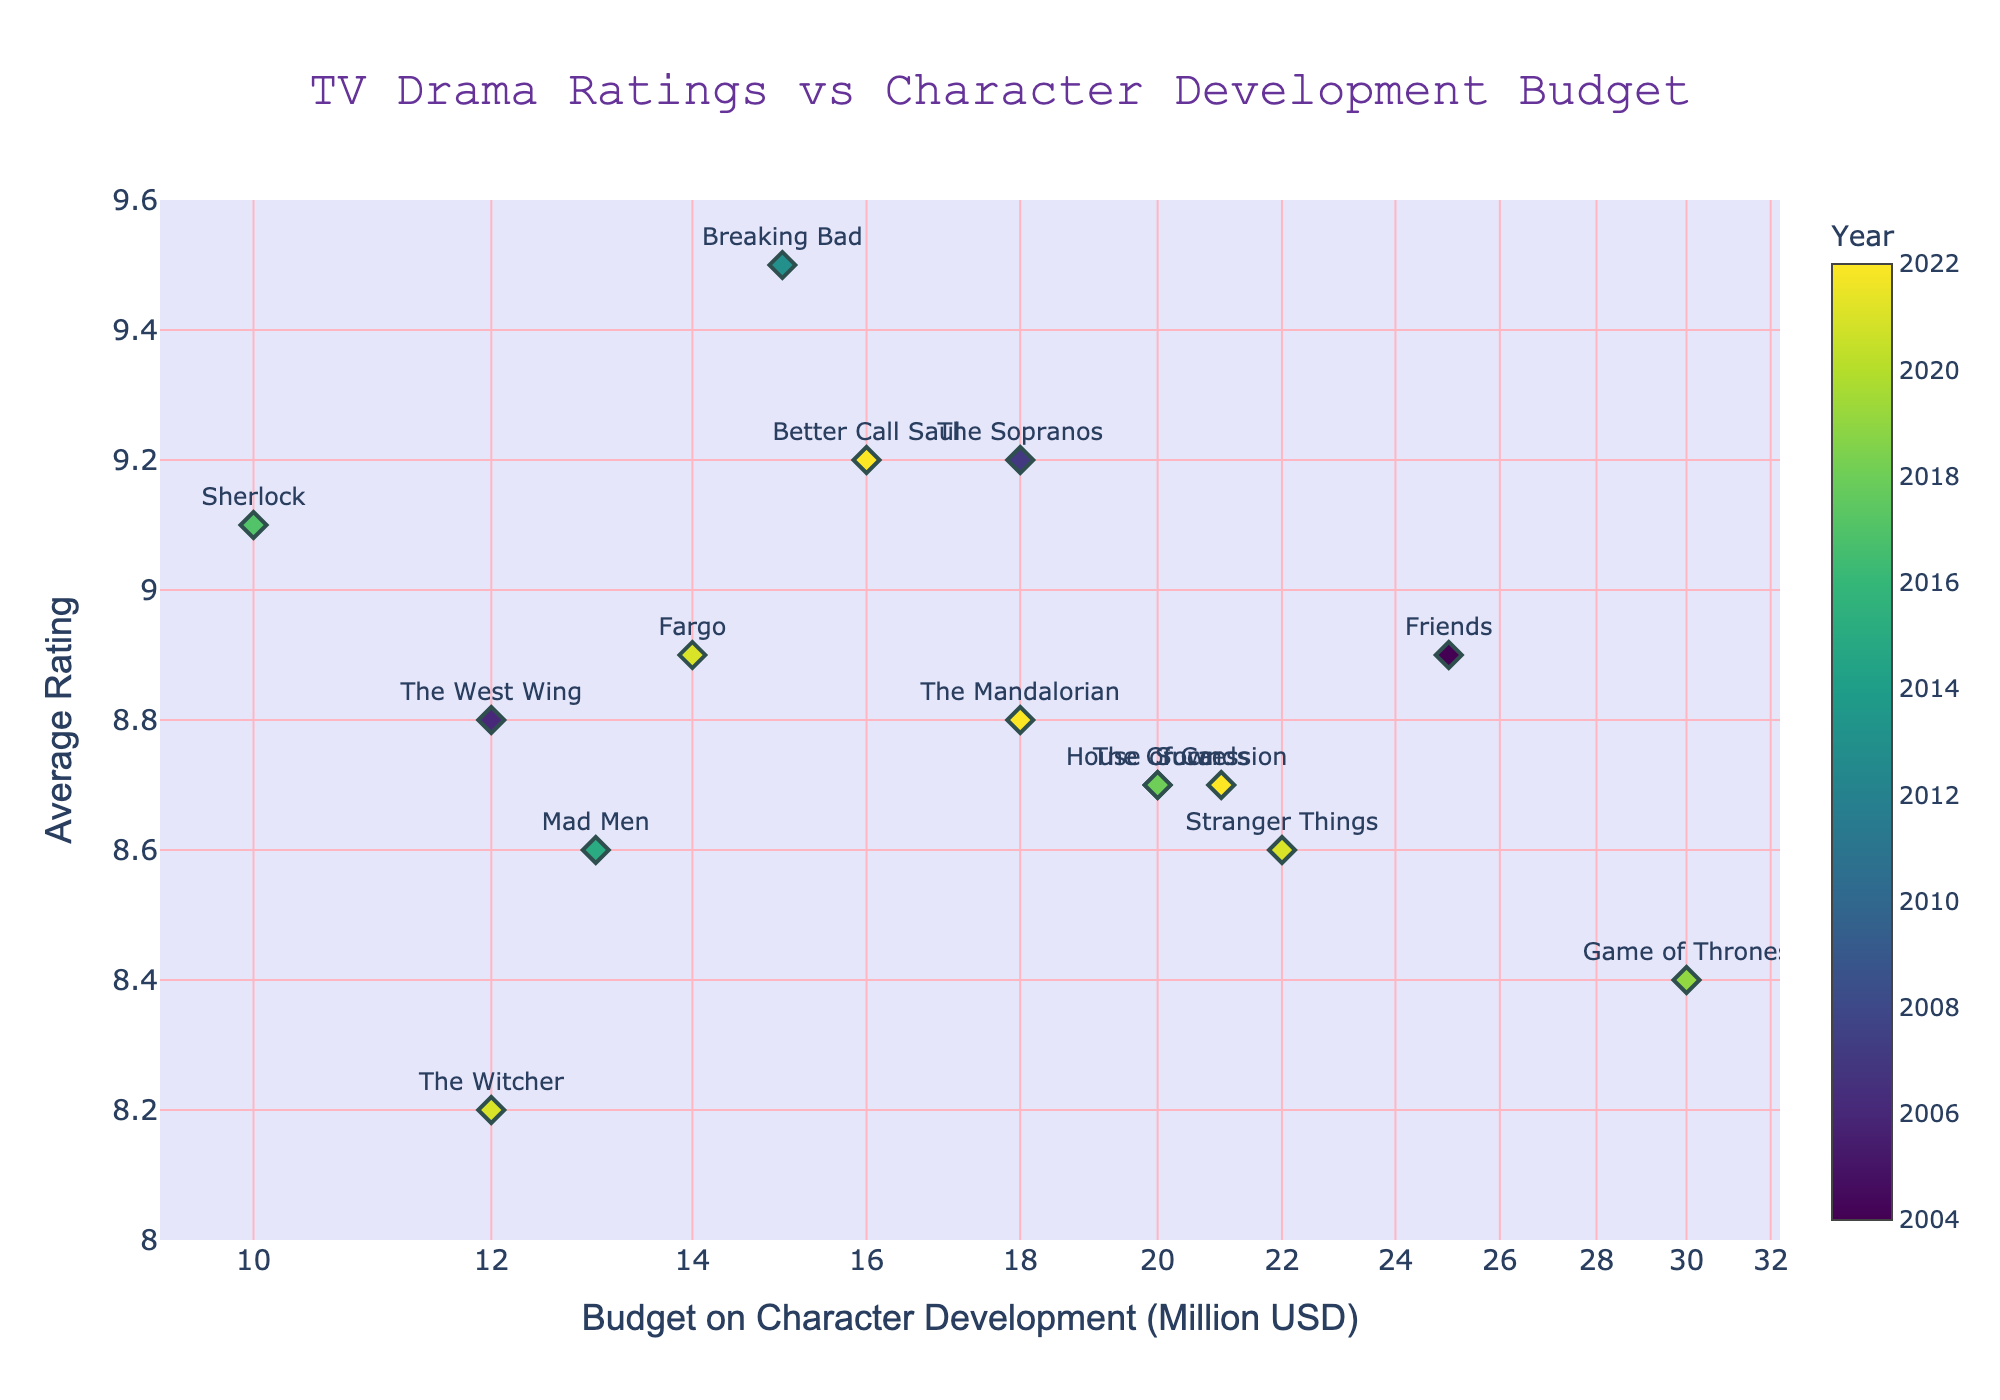What's the title of the plot? Look at the large, centrally aligned text at the top of the plot.
Answer: TV Drama Ratings vs Character Development Budget What is the budget on character development for 'Friends' and its rating? Hover over the data point labeled 'Friends' to see the budget and rating details in the hover template.
Answer: $25M, 8.9 Which TV drama has the highest average rating and what is that rating? Look for the data point at the highest y-axis value and read the label.
Answer: Breaking Bad, 9.5 How does the rating of 'Stranger Things' compare to 'The Witcher'? Locate the data points for 'Stranger Things' and 'The Witcher' and compare their y-axis values (ratings).
Answer: Stranger Things has a higher rating What is the range of budget values shown in the plot? Observe the x-axis, which is on a log scale, to determine the lowest and highest budgets.
Answer: From $10M to $30M How do the budgets of 'Game of Thrones' and 'Succession' compare? Compare the x-axis positions (budget values) of the data points for 'Game of Thrones' and 'Succession'.
Answer: Game of Thrones has a higher budget Which TV drama from 2021 has the highest rating and what is that rating? Identify the data points from the year 2021 and check their y-axis values to find the highest rating.
Answer: Fargo, 8.9 Calculate the average rating of TV dramas with a budget less than $20M. Identify the data points with an x-axis value less than 20 and calculate their average y-axis value. (Breaking Bad: 9.5, The Sopranos: 9.2, Sherlock: 9.1, The West Wing: 8.8, Mad Men: 8.6, Fargo: 8.9, The Witcher: 8.2. Total: 62.3, Number of dramas: 7)
Answer: 8.9 What is the visual indicator used to represent the year of the TV dramas? The plot uses colors on a colorscale to represent the year values. Observe the colorbar to confirm.
Answer: Colorscale Which TV drama had the biggest budget and what is its rating? Find the data point with the highest x-axis value and read off its y-axis value (rating).
Answer: Game of Thrones, 8.4 